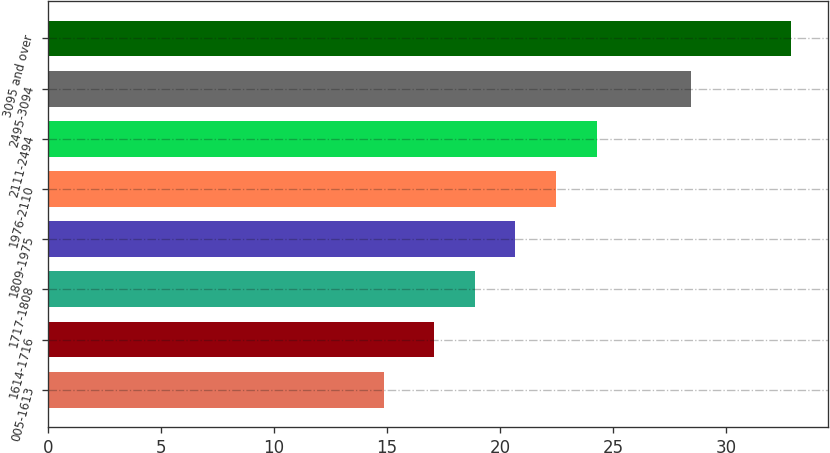<chart> <loc_0><loc_0><loc_500><loc_500><bar_chart><fcel>005-1613<fcel>1614-1716<fcel>1717-1808<fcel>1809-1975<fcel>1976-2110<fcel>2111-2494<fcel>2495-3094<fcel>3095 and over<nl><fcel>14.87<fcel>17.07<fcel>18.87<fcel>20.67<fcel>22.47<fcel>24.27<fcel>28.42<fcel>32.84<nl></chart> 